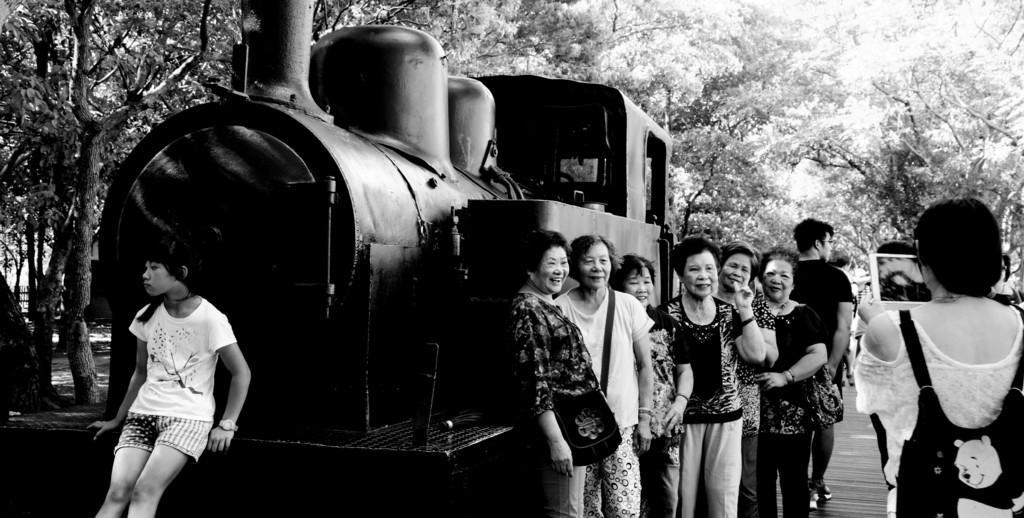How would you summarize this image in a sentence or two? Here we can see a black and white photograph, in this picture we can see a train and group of people, on the right side of the image we can see a woman, she is carrying a bag and she is holding a tablet, in the background we can find few trees. 